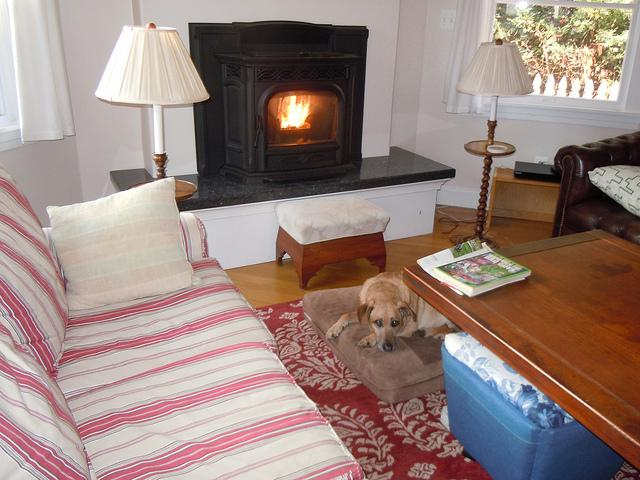What is the dog lying on?

Choices:
A) couch cushion
B) head rest
C) blanket
D) dog bed dog bed 